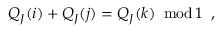<formula> <loc_0><loc_0><loc_500><loc_500>Q _ { J } ( i ) + Q _ { J } ( j ) = Q _ { J } ( k ) \, m o d \, 1 \, ,</formula> 